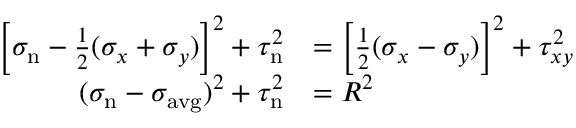<formula> <loc_0><loc_0><loc_500><loc_500>{ \begin{array} { r l } { \left [ \sigma _ { n } - { \frac { 1 } { 2 } } ( \sigma _ { x } + \sigma _ { y } ) \right ] ^ { 2 } + \tau _ { n } ^ { 2 } } & { = \left [ { \frac { 1 } { 2 } } ( \sigma _ { x } - \sigma _ { y } ) \right ] ^ { 2 } + \tau _ { x y } ^ { 2 } } \\ { ( \sigma _ { n } - \sigma _ { a v g } ) ^ { 2 } + \tau _ { n } ^ { 2 } } & { = R ^ { 2 } } \end{array} }</formula> 